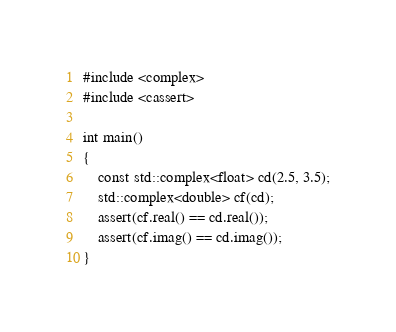<code> <loc_0><loc_0><loc_500><loc_500><_C++_>
#include <complex>
#include <cassert>

int main()
{
    const std::complex<float> cd(2.5, 3.5);
    std::complex<double> cf(cd);
    assert(cf.real() == cd.real());
    assert(cf.imag() == cd.imag());
}
</code> 